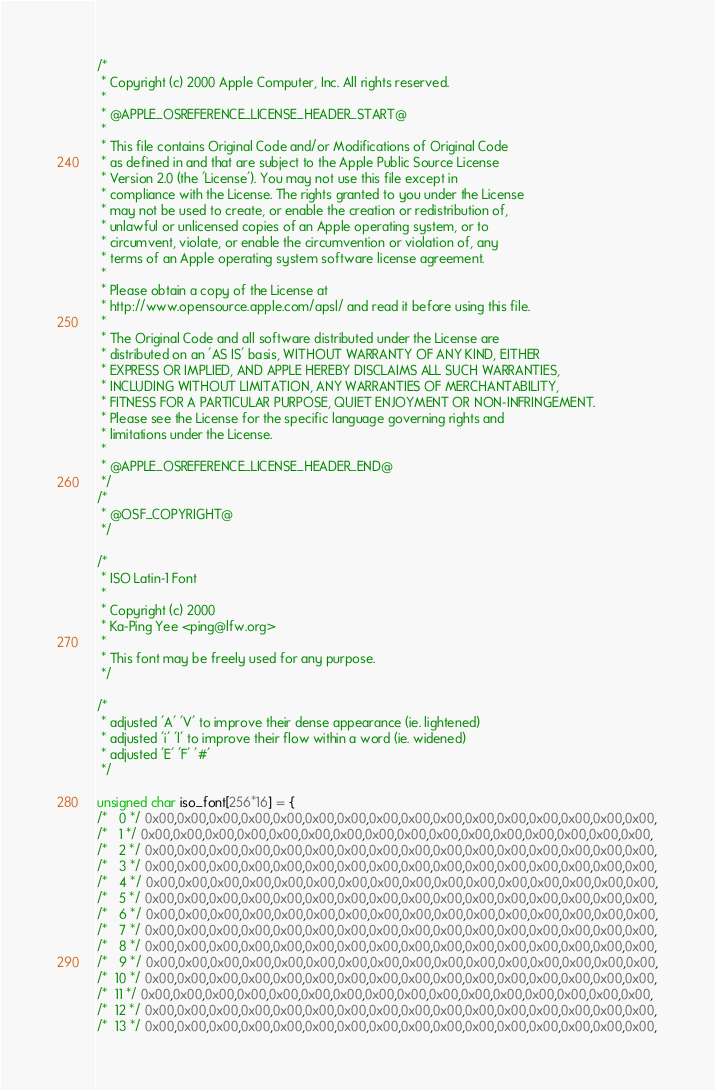<code> <loc_0><loc_0><loc_500><loc_500><_C_>/*
 * Copyright (c) 2000 Apple Computer, Inc. All rights reserved.
 *
 * @APPLE_OSREFERENCE_LICENSE_HEADER_START@
 * 
 * This file contains Original Code and/or Modifications of Original Code
 * as defined in and that are subject to the Apple Public Source License
 * Version 2.0 (the 'License'). You may not use this file except in
 * compliance with the License. The rights granted to you under the License
 * may not be used to create, or enable the creation or redistribution of,
 * unlawful or unlicensed copies of an Apple operating system, or to
 * circumvent, violate, or enable the circumvention or violation of, any
 * terms of an Apple operating system software license agreement.
 * 
 * Please obtain a copy of the License at
 * http://www.opensource.apple.com/apsl/ and read it before using this file.
 * 
 * The Original Code and all software distributed under the License are
 * distributed on an 'AS IS' basis, WITHOUT WARRANTY OF ANY KIND, EITHER
 * EXPRESS OR IMPLIED, AND APPLE HEREBY DISCLAIMS ALL SUCH WARRANTIES,
 * INCLUDING WITHOUT LIMITATION, ANY WARRANTIES OF MERCHANTABILITY,
 * FITNESS FOR A PARTICULAR PURPOSE, QUIET ENJOYMENT OR NON-INFRINGEMENT.
 * Please see the License for the specific language governing rights and
 * limitations under the License.
 * 
 * @APPLE_OSREFERENCE_LICENSE_HEADER_END@
 */
/*
 * @OSF_COPYRIGHT@
 */

/*
 * ISO Latin-1 Font
 *
 * Copyright (c) 2000
 * Ka-Ping Yee <ping@lfw.org>
 *
 * This font may be freely used for any purpose.
 */

/*
 * adjusted 'A' 'V' to improve their dense appearance (ie. lightened)
 * adjusted 'i' 'l' to improve their flow within a word (ie. widened)
 * adjusted 'E' 'F' '#'
 */

unsigned char iso_font[256*16] = {
/*   0 */ 0x00,0x00,0x00,0x00,0x00,0x00,0x00,0x00,0x00,0x00,0x00,0x00,0x00,0x00,0x00,0x00,
/*   1 */ 0x00,0x00,0x00,0x00,0x00,0x00,0x00,0x00,0x00,0x00,0x00,0x00,0x00,0x00,0x00,0x00,
/*   2 */ 0x00,0x00,0x00,0x00,0x00,0x00,0x00,0x00,0x00,0x00,0x00,0x00,0x00,0x00,0x00,0x00,
/*   3 */ 0x00,0x00,0x00,0x00,0x00,0x00,0x00,0x00,0x00,0x00,0x00,0x00,0x00,0x00,0x00,0x00,
/*   4 */ 0x00,0x00,0x00,0x00,0x00,0x00,0x00,0x00,0x00,0x00,0x00,0x00,0x00,0x00,0x00,0x00,
/*   5 */ 0x00,0x00,0x00,0x00,0x00,0x00,0x00,0x00,0x00,0x00,0x00,0x00,0x00,0x00,0x00,0x00,
/*   6 */ 0x00,0x00,0x00,0x00,0x00,0x00,0x00,0x00,0x00,0x00,0x00,0x00,0x00,0x00,0x00,0x00,
/*   7 */ 0x00,0x00,0x00,0x00,0x00,0x00,0x00,0x00,0x00,0x00,0x00,0x00,0x00,0x00,0x00,0x00,
/*   8 */ 0x00,0x00,0x00,0x00,0x00,0x00,0x00,0x00,0x00,0x00,0x00,0x00,0x00,0x00,0x00,0x00,
/*   9 */ 0x00,0x00,0x00,0x00,0x00,0x00,0x00,0x00,0x00,0x00,0x00,0x00,0x00,0x00,0x00,0x00,
/*  10 */ 0x00,0x00,0x00,0x00,0x00,0x00,0x00,0x00,0x00,0x00,0x00,0x00,0x00,0x00,0x00,0x00,
/*  11 */ 0x00,0x00,0x00,0x00,0x00,0x00,0x00,0x00,0x00,0x00,0x00,0x00,0x00,0x00,0x00,0x00,
/*  12 */ 0x00,0x00,0x00,0x00,0x00,0x00,0x00,0x00,0x00,0x00,0x00,0x00,0x00,0x00,0x00,0x00,
/*  13 */ 0x00,0x00,0x00,0x00,0x00,0x00,0x00,0x00,0x00,0x00,0x00,0x00,0x00,0x00,0x00,0x00,</code> 